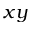Convert formula to latex. <formula><loc_0><loc_0><loc_500><loc_500>x y</formula> 